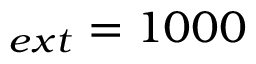<formula> <loc_0><loc_0><loc_500><loc_500>_ { e x t } = 1 0 0 0</formula> 